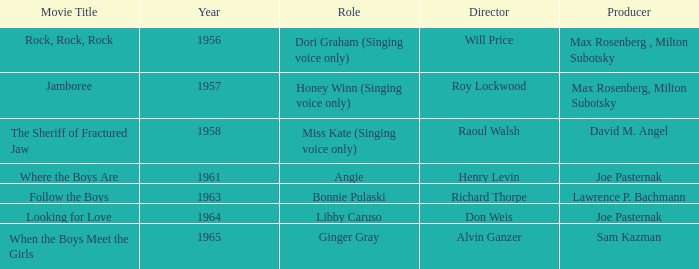What were the roles in 1961? Angie. 